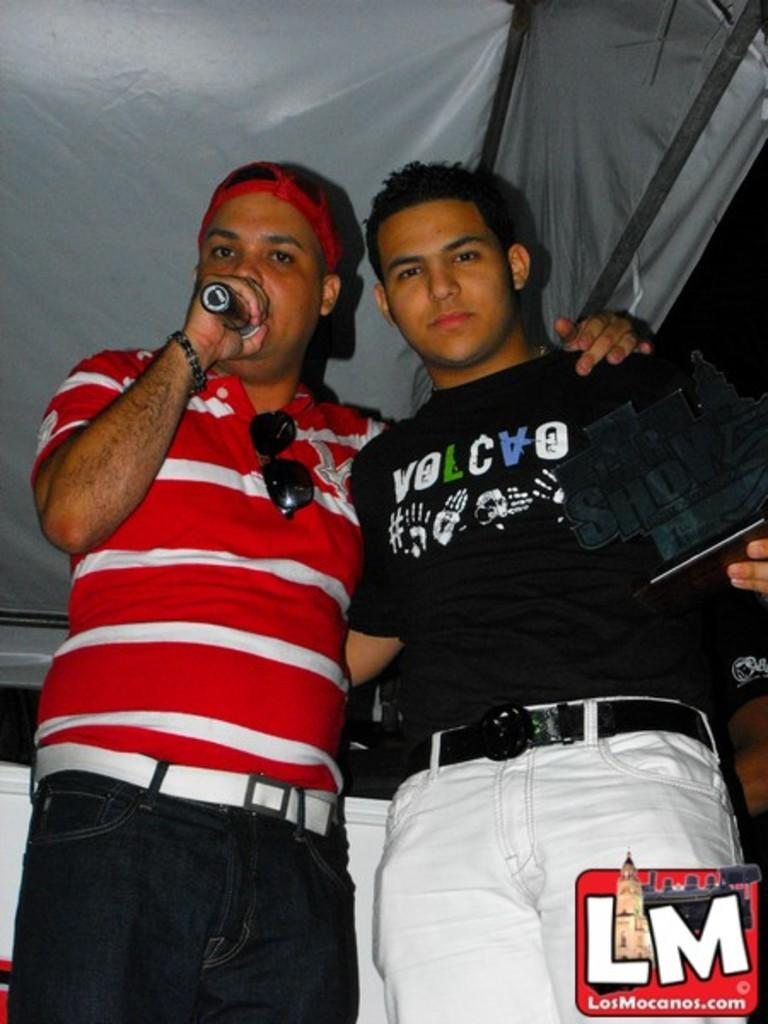<image>
Summarize the visual content of the image. two guys with a mike ones shirt says volocao 